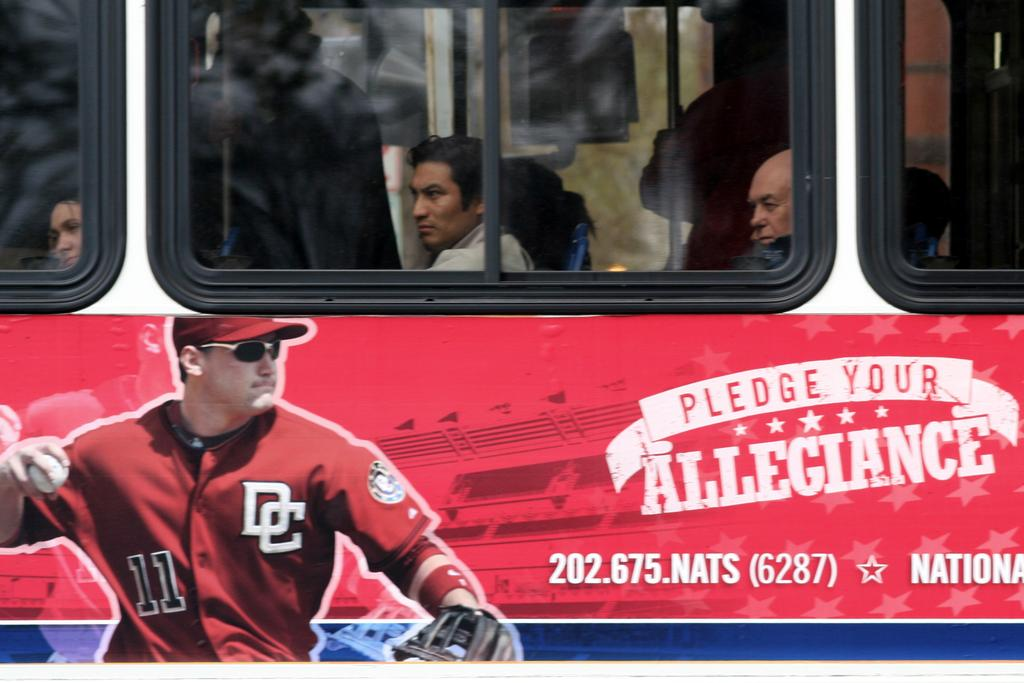<image>
Offer a succinct explanation of the picture presented. A bus has an image of a baseball player and the words 'Pledge your Allegiance' on it. 